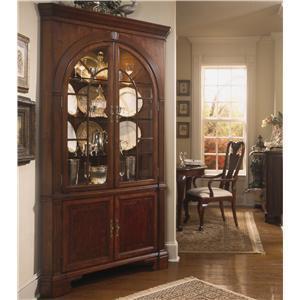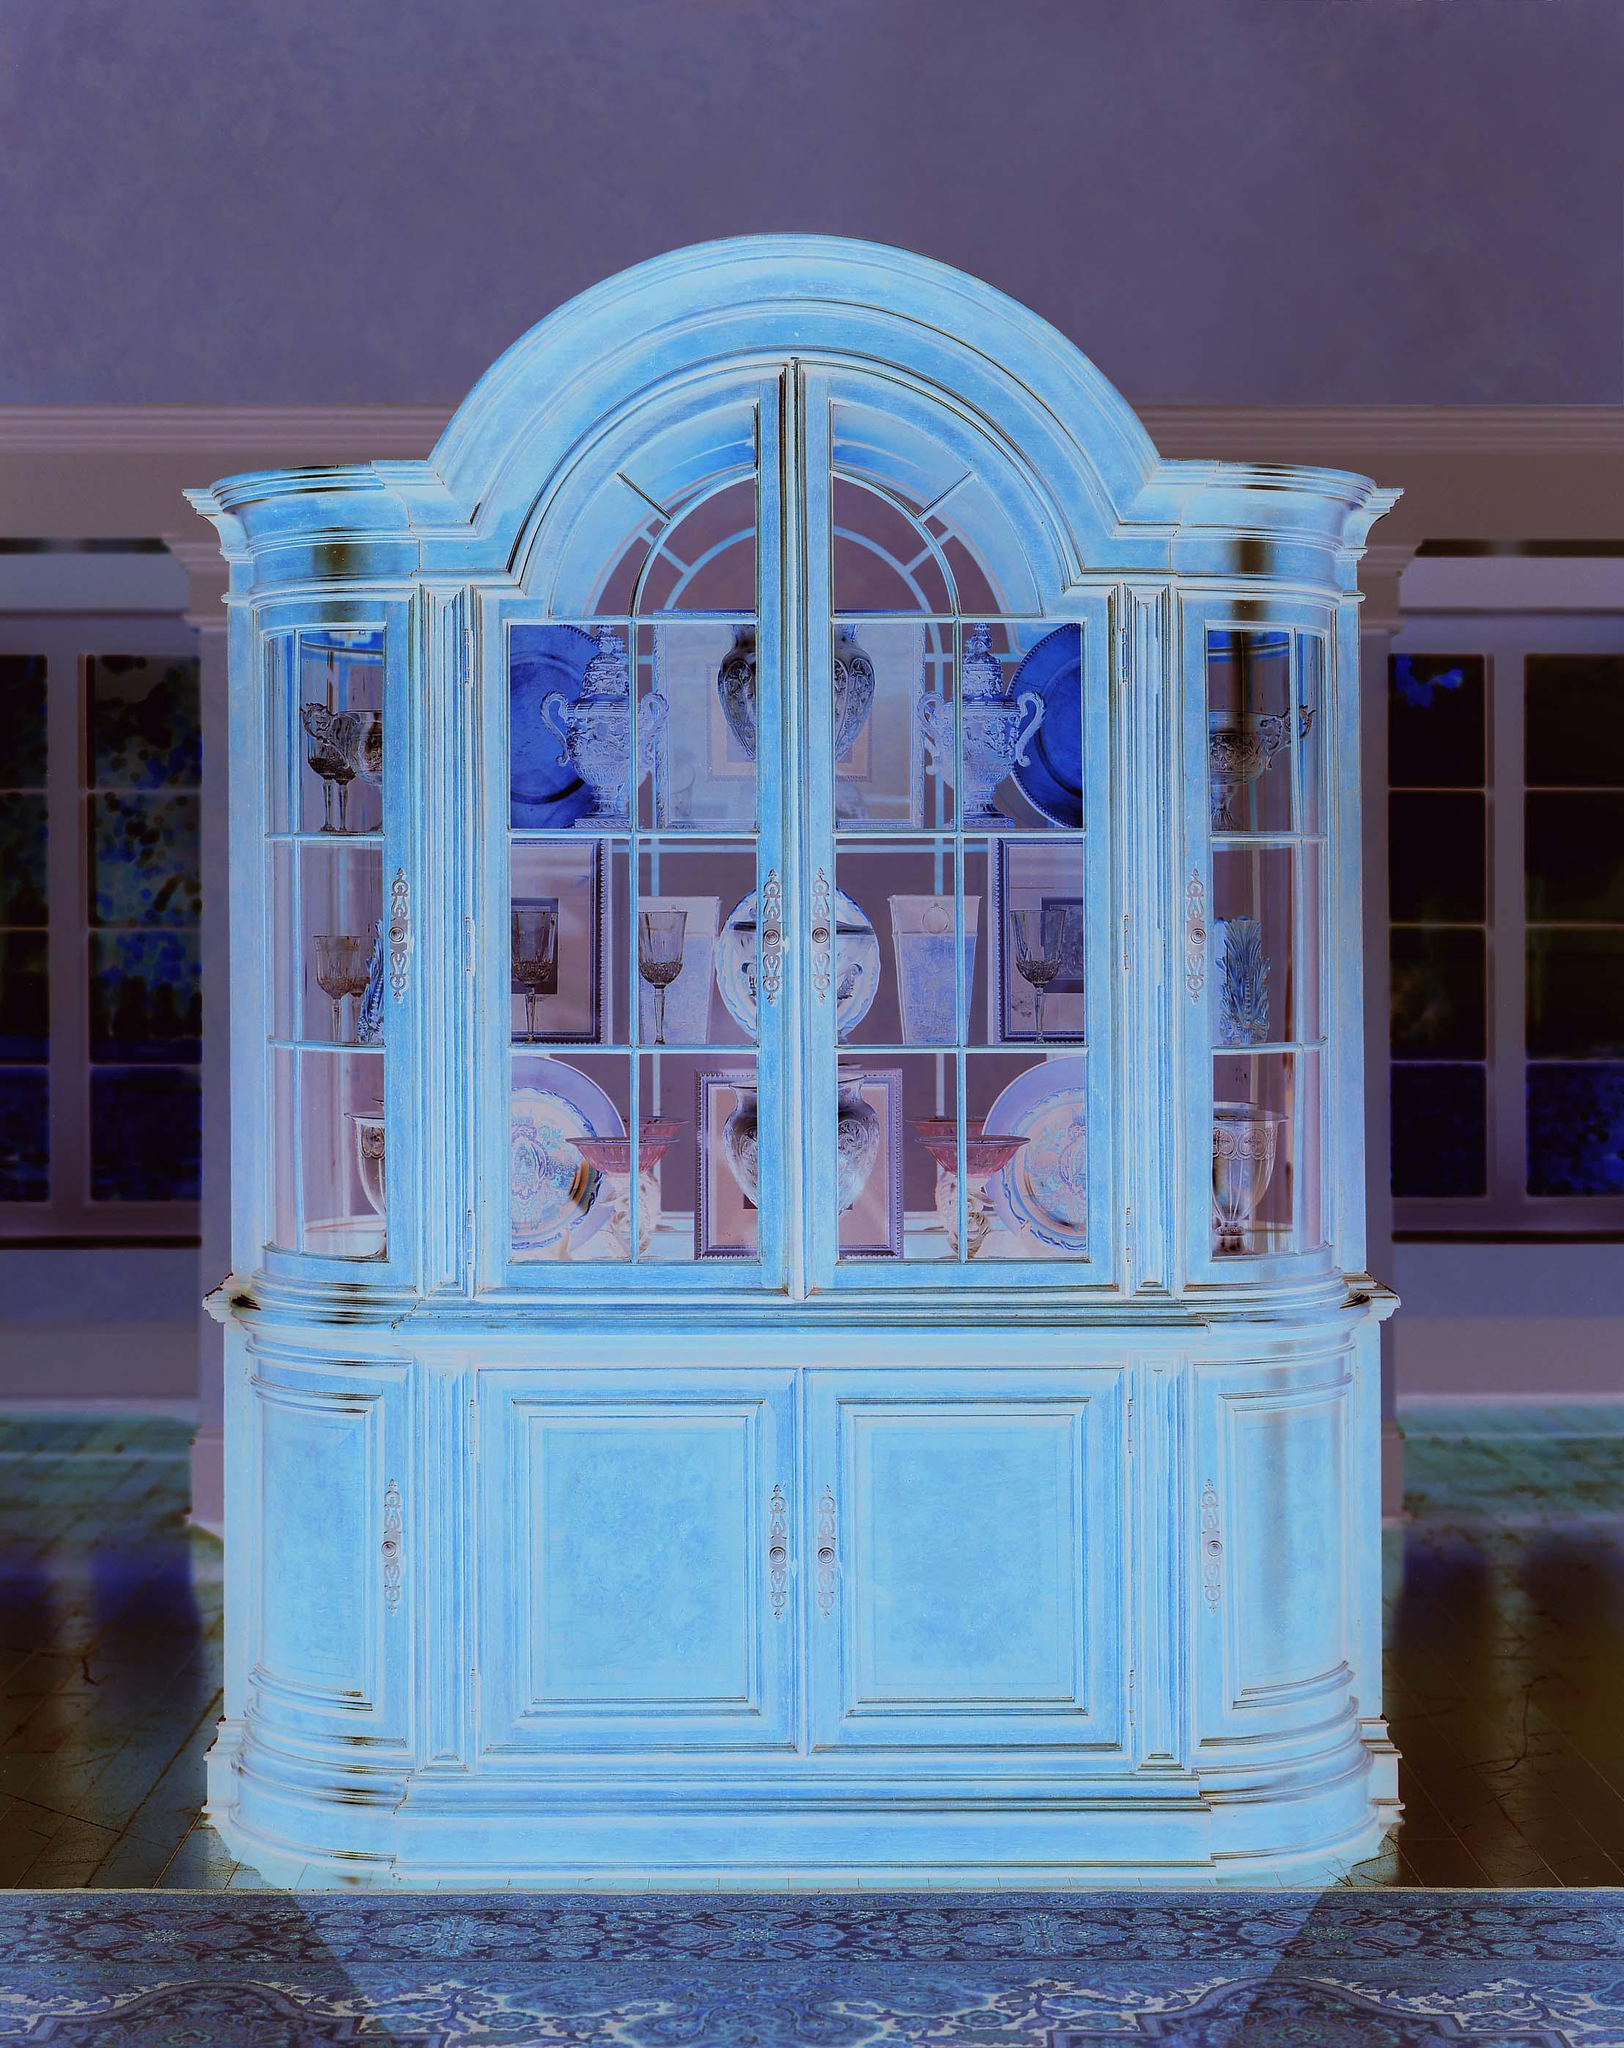The first image is the image on the left, the second image is the image on the right. Given the left and right images, does the statement "All furniture on the images are brown" hold true? Answer yes or no. No. 